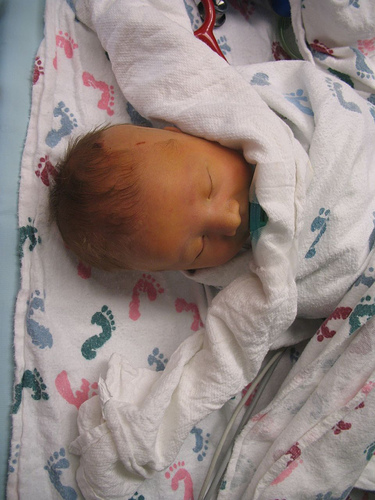<image>
Can you confirm if the baby is to the right of the blanket? No. The baby is not to the right of the blanket. The horizontal positioning shows a different relationship. Is there a baby above the blanket? No. The baby is not positioned above the blanket. The vertical arrangement shows a different relationship. 